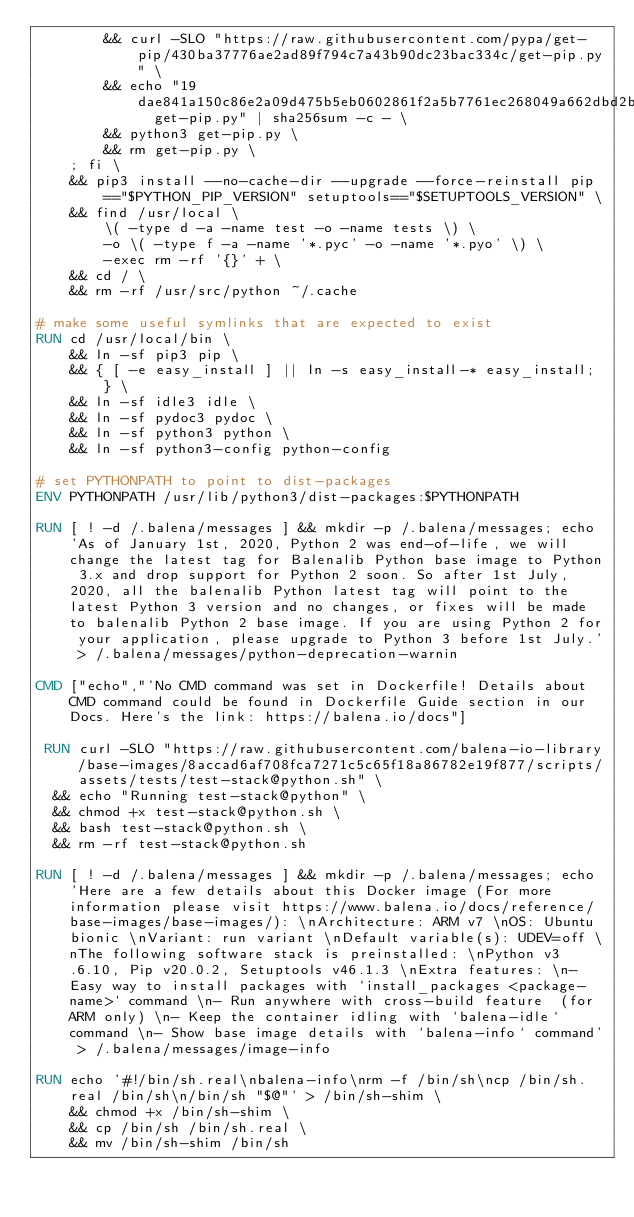<code> <loc_0><loc_0><loc_500><loc_500><_Dockerfile_>		&& curl -SLO "https://raw.githubusercontent.com/pypa/get-pip/430ba37776ae2ad89f794c7a43b90dc23bac334c/get-pip.py" \
		&& echo "19dae841a150c86e2a09d475b5eb0602861f2a5b7761ec268049a662dbd2bd0c  get-pip.py" | sha256sum -c - \
		&& python3 get-pip.py \
		&& rm get-pip.py \
	; fi \
	&& pip3 install --no-cache-dir --upgrade --force-reinstall pip=="$PYTHON_PIP_VERSION" setuptools=="$SETUPTOOLS_VERSION" \
	&& find /usr/local \
		\( -type d -a -name test -o -name tests \) \
		-o \( -type f -a -name '*.pyc' -o -name '*.pyo' \) \
		-exec rm -rf '{}' + \
	&& cd / \
	&& rm -rf /usr/src/python ~/.cache

# make some useful symlinks that are expected to exist
RUN cd /usr/local/bin \
	&& ln -sf pip3 pip \
	&& { [ -e easy_install ] || ln -s easy_install-* easy_install; } \
	&& ln -sf idle3 idle \
	&& ln -sf pydoc3 pydoc \
	&& ln -sf python3 python \
	&& ln -sf python3-config python-config

# set PYTHONPATH to point to dist-packages
ENV PYTHONPATH /usr/lib/python3/dist-packages:$PYTHONPATH

RUN [ ! -d /.balena/messages ] && mkdir -p /.balena/messages; echo 'As of January 1st, 2020, Python 2 was end-of-life, we will change the latest tag for Balenalib Python base image to Python 3.x and drop support for Python 2 soon. So after 1st July, 2020, all the balenalib Python latest tag will point to the latest Python 3 version and no changes, or fixes will be made to balenalib Python 2 base image. If you are using Python 2 for your application, please upgrade to Python 3 before 1st July.' > /.balena/messages/python-deprecation-warnin

CMD ["echo","'No CMD command was set in Dockerfile! Details about CMD command could be found in Dockerfile Guide section in our Docs. Here's the link: https://balena.io/docs"]

 RUN curl -SLO "https://raw.githubusercontent.com/balena-io-library/base-images/8accad6af708fca7271c5c65f18a86782e19f877/scripts/assets/tests/test-stack@python.sh" \
  && echo "Running test-stack@python" \
  && chmod +x test-stack@python.sh \
  && bash test-stack@python.sh \
  && rm -rf test-stack@python.sh 

RUN [ ! -d /.balena/messages ] && mkdir -p /.balena/messages; echo 'Here are a few details about this Docker image (For more information please visit https://www.balena.io/docs/reference/base-images/base-images/): \nArchitecture: ARM v7 \nOS: Ubuntu bionic \nVariant: run variant \nDefault variable(s): UDEV=off \nThe following software stack is preinstalled: \nPython v3.6.10, Pip v20.0.2, Setuptools v46.1.3 \nExtra features: \n- Easy way to install packages with `install_packages <package-name>` command \n- Run anywhere with cross-build feature  (for ARM only) \n- Keep the container idling with `balena-idle` command \n- Show base image details with `balena-info` command' > /.balena/messages/image-info

RUN echo '#!/bin/sh.real\nbalena-info\nrm -f /bin/sh\ncp /bin/sh.real /bin/sh\n/bin/sh "$@"' > /bin/sh-shim \
	&& chmod +x /bin/sh-shim \
	&& cp /bin/sh /bin/sh.real \
	&& mv /bin/sh-shim /bin/sh</code> 